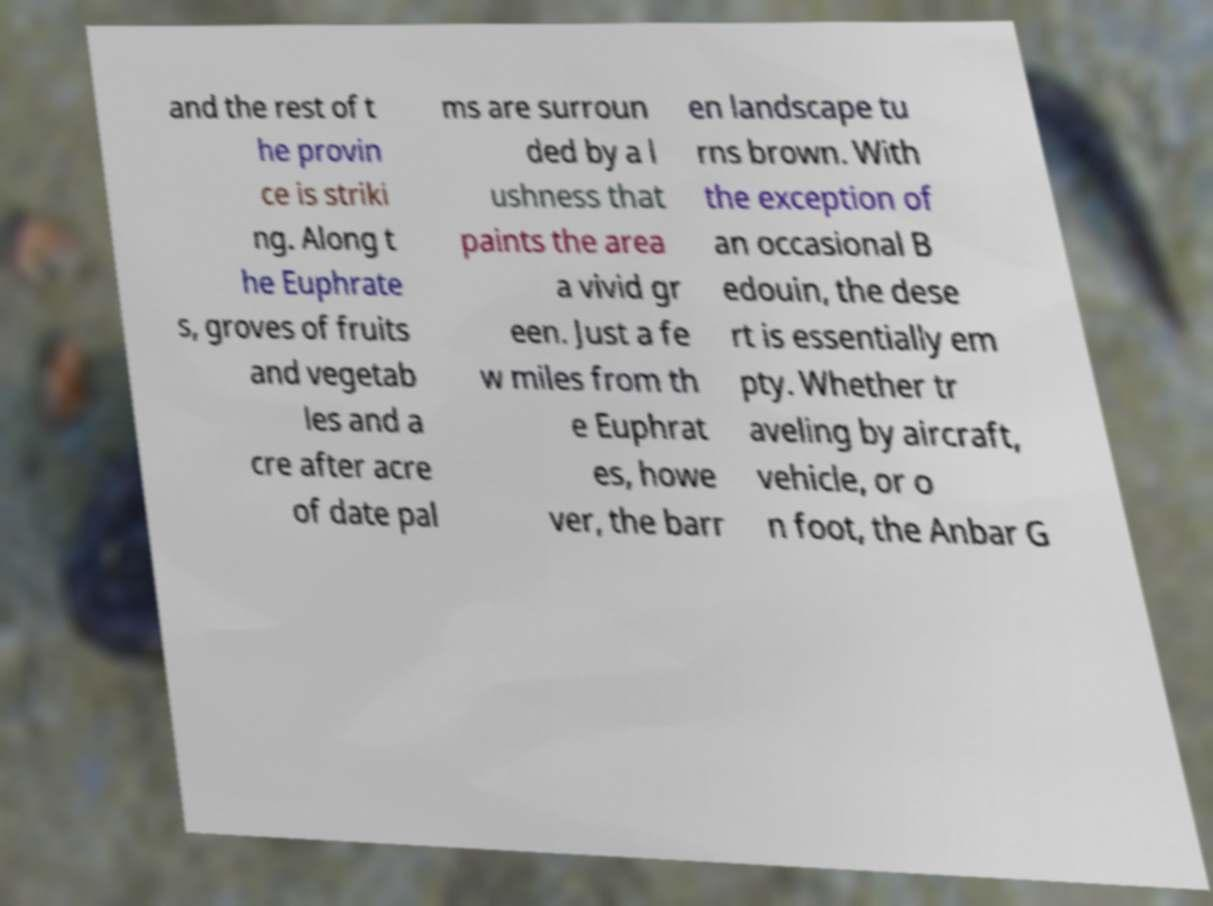Please read and relay the text visible in this image. What does it say? and the rest of t he provin ce is striki ng. Along t he Euphrate s, groves of fruits and vegetab les and a cre after acre of date pal ms are surroun ded by a l ushness that paints the area a vivid gr een. Just a fe w miles from th e Euphrat es, howe ver, the barr en landscape tu rns brown. With the exception of an occasional B edouin, the dese rt is essentially em pty. Whether tr aveling by aircraft, vehicle, or o n foot, the Anbar G 